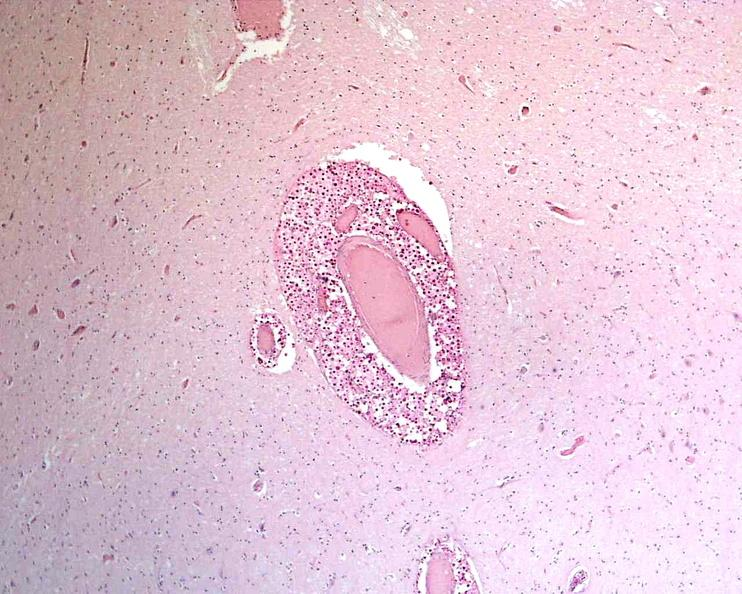what does this image show?
Answer the question using a single word or phrase. Brain 